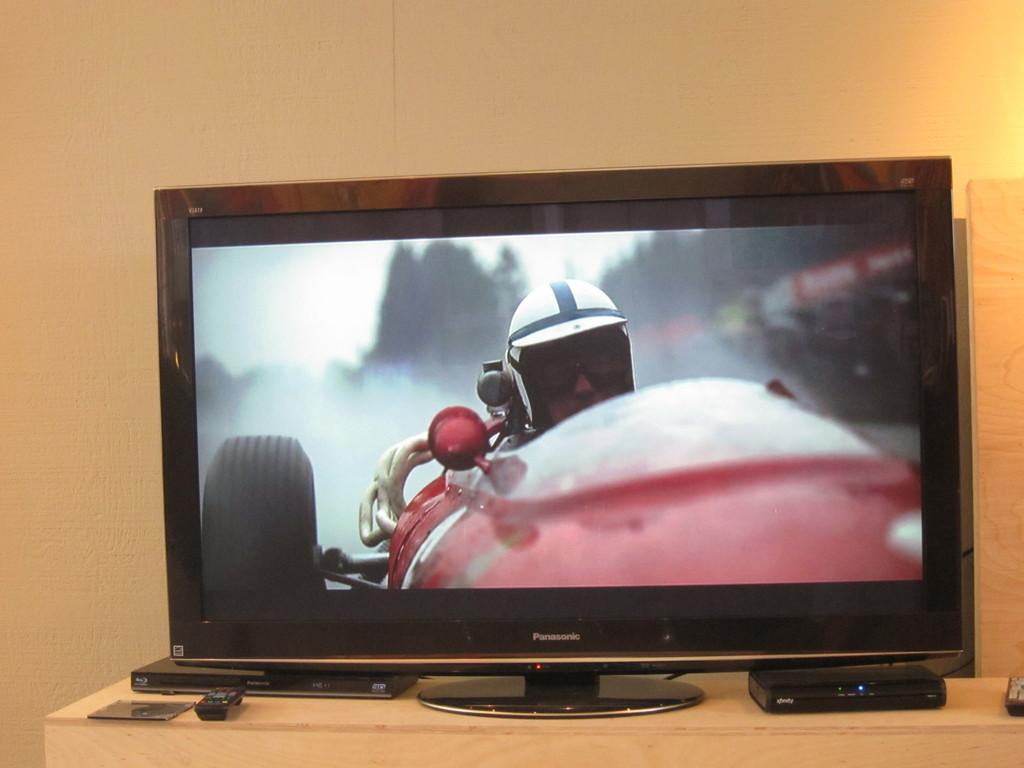<image>
Offer a succinct explanation of the picture presented. a Panasonic brand tv monitor shows an old fashioned race car driver on the screen 